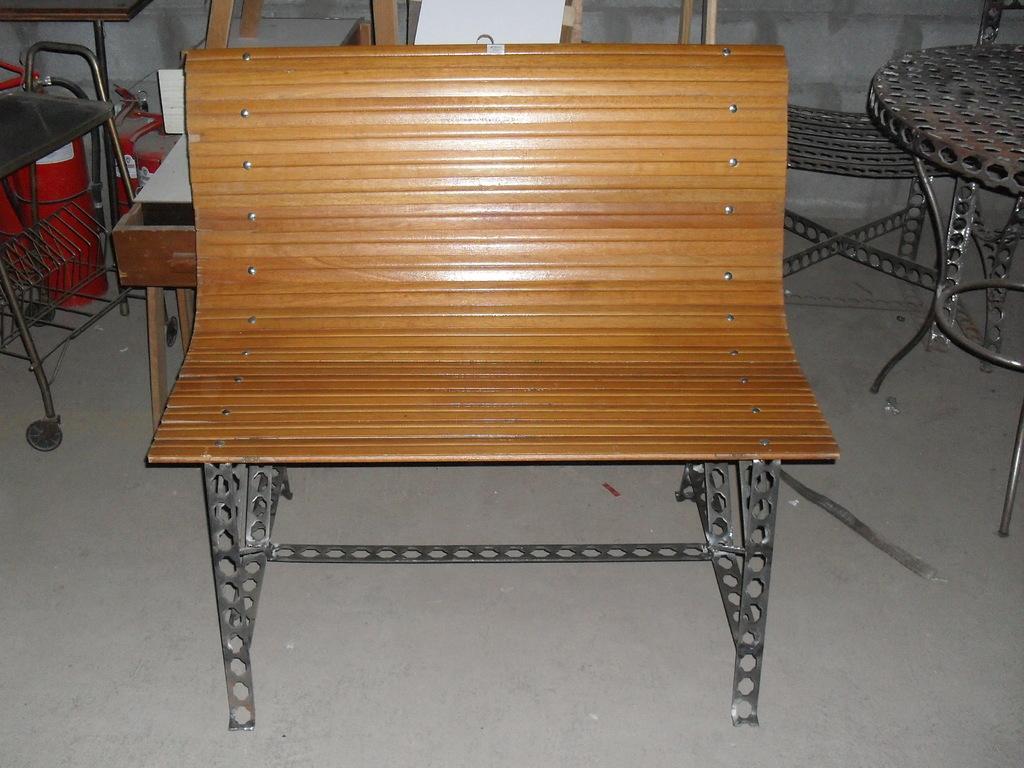In one or two sentences, can you explain what this image depicts? In the middle of the picture, we see a bench and beside that, we see an iron table and behind that, there is an iron chair. On the left corner of the picture, we see a chair and behind the bench, we see wooden chairs. This picture might be clicked inside the room. 